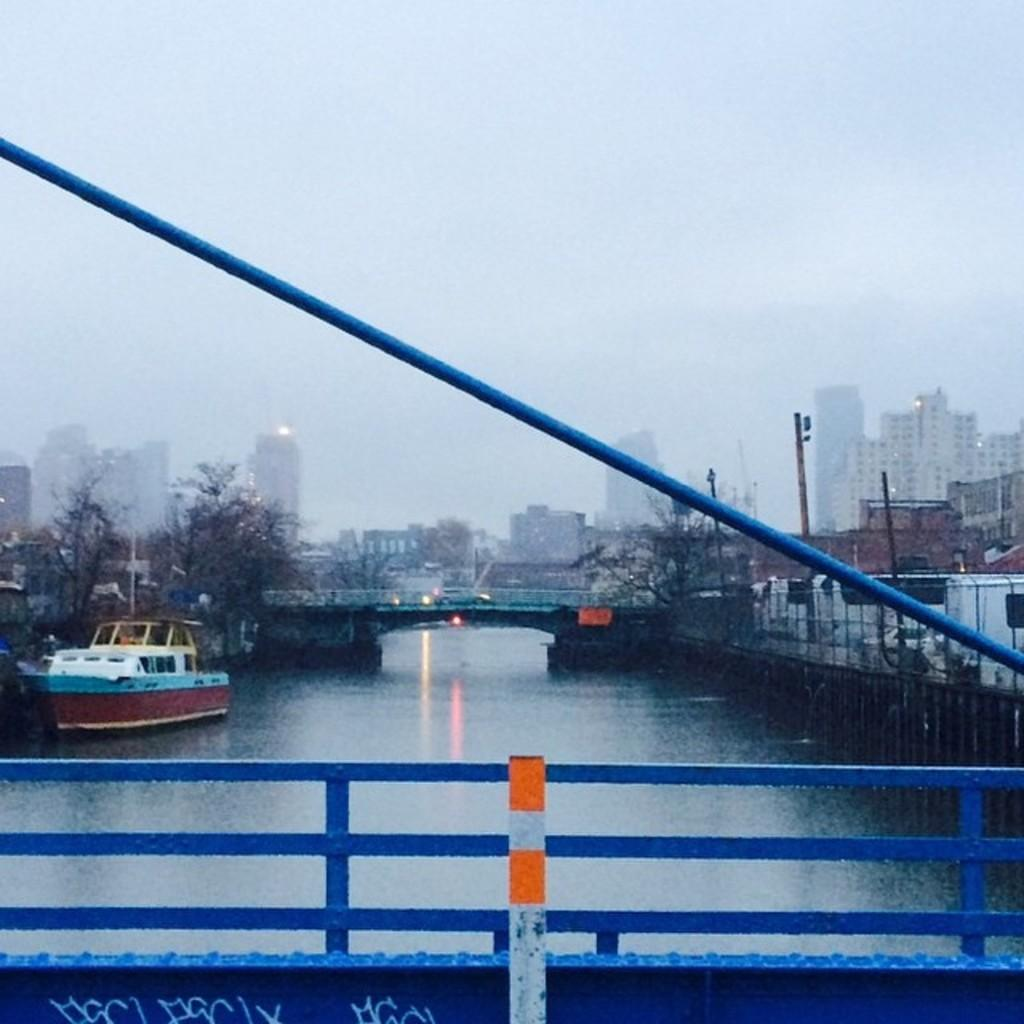What type of structure is in the image? There is a metal bridge in the image. What is the bridge positioned over? The bridge is over a small river. What can be seen in the background of the image? There are buildings and dry trees in the background of the image. What is the color of the railing on the bridge? The railing on the bridge is blue. What type of cast can be seen on the bridge in the image? There is no cast present on the bridge in the image. Is the image taken during the night? The image does not provide any information about the time of day, so it cannot be determined if it was taken during the night. 